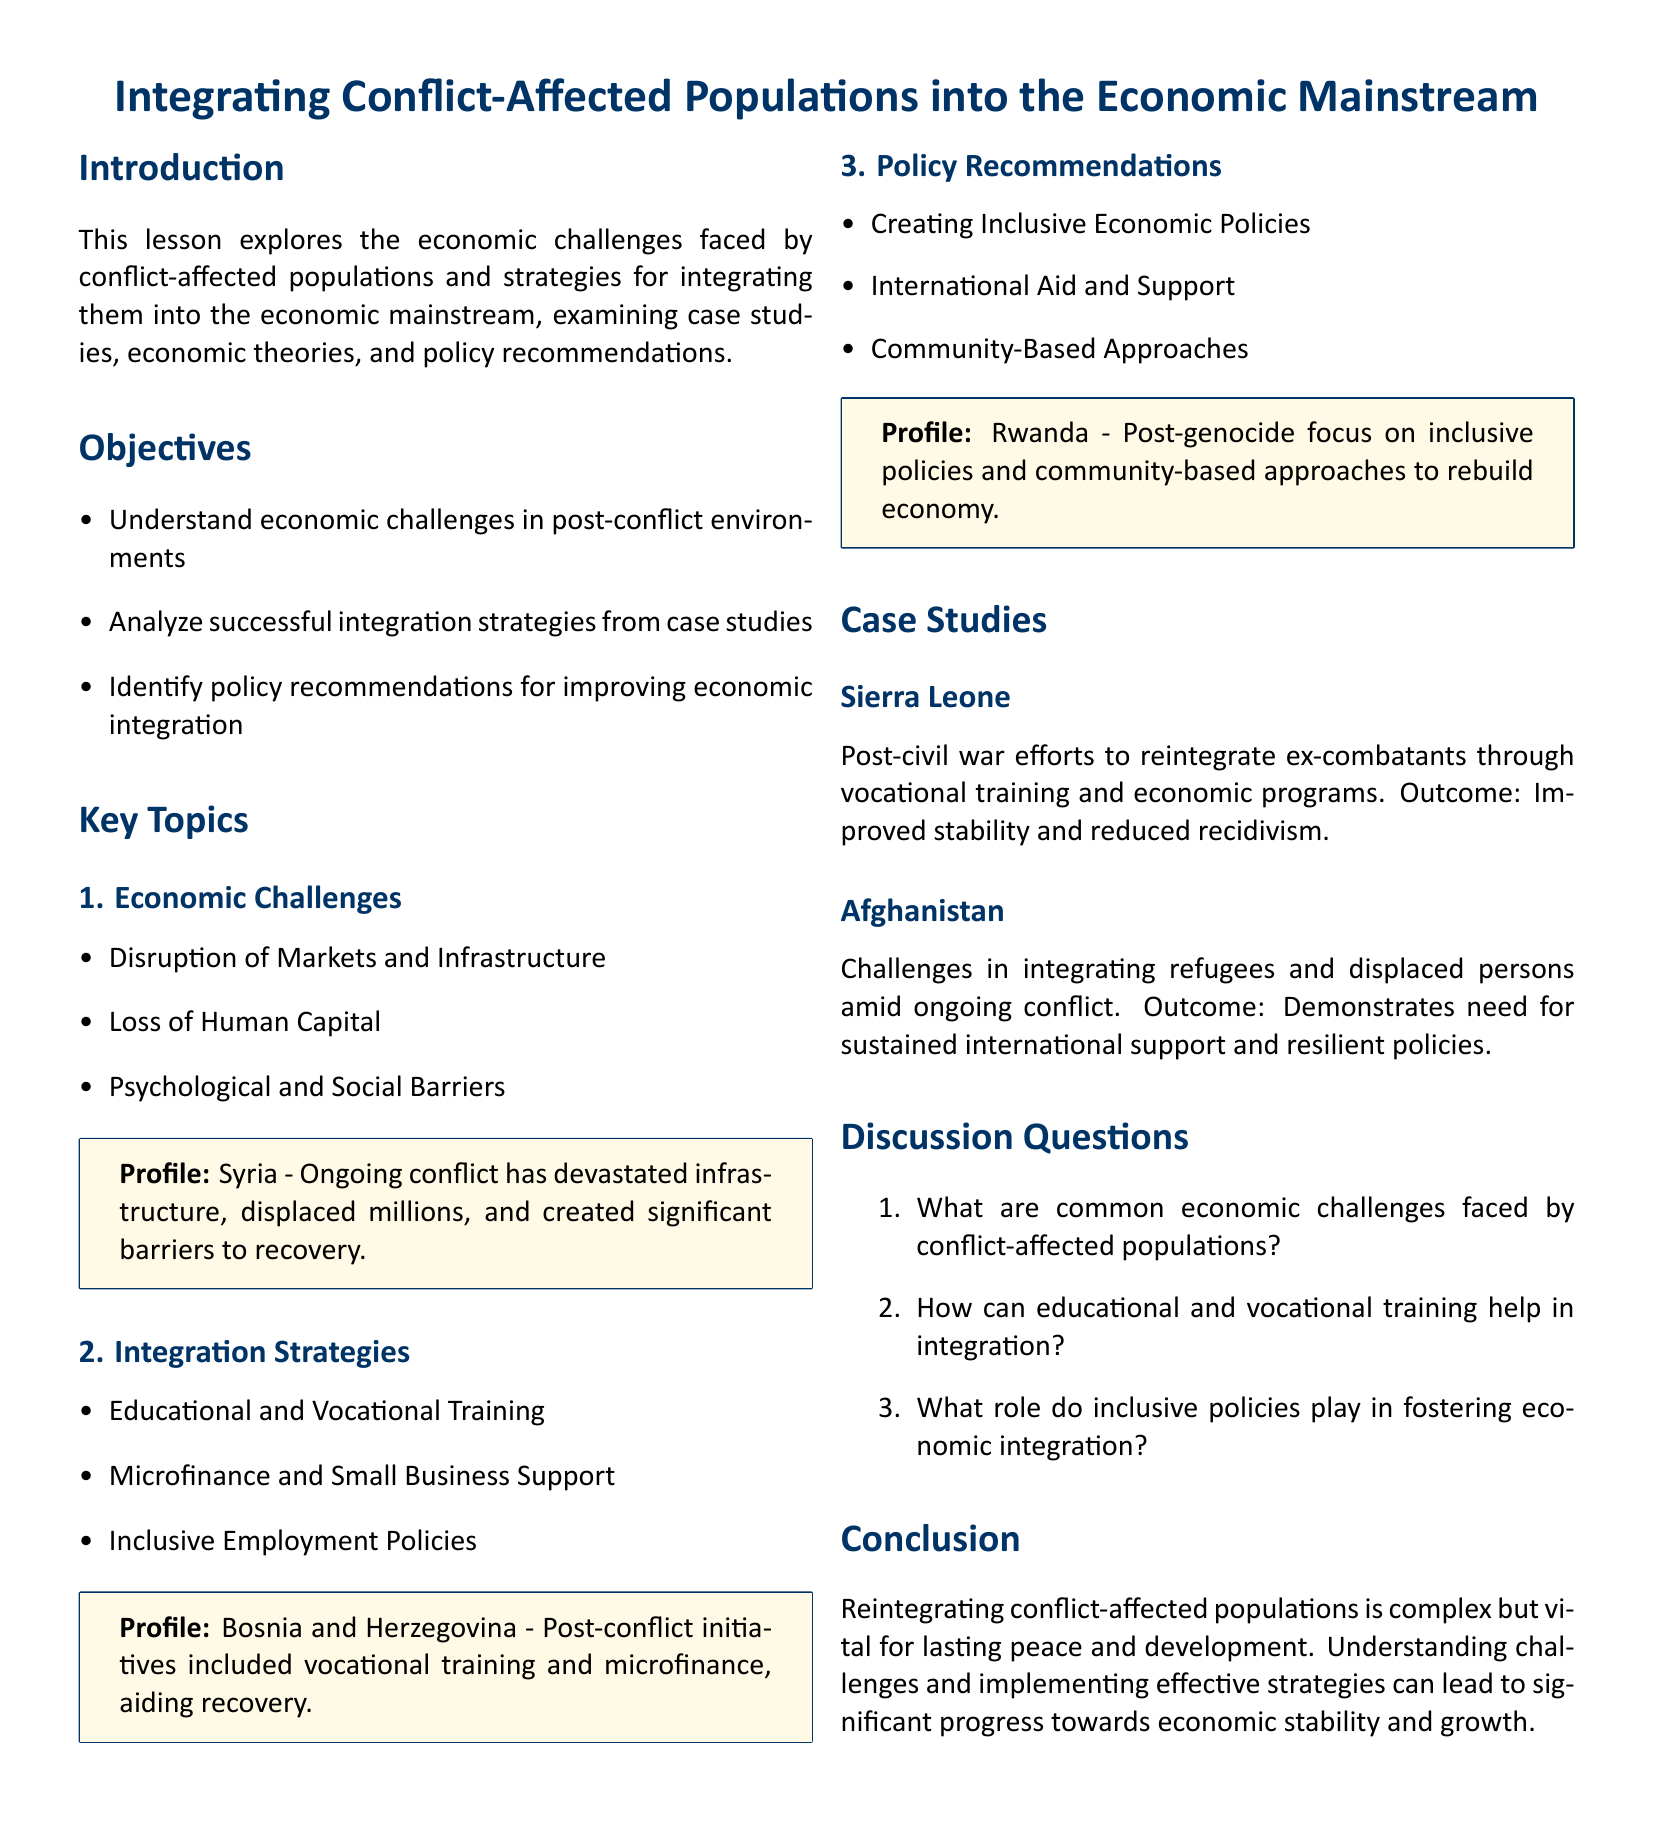What are the economic challenges faced by conflict-affected populations? The document lists several economic challenges including market disruption, loss of human capital, and psychological barriers.
Answer: Market disruption, loss of human capital, psychological barriers What case study is mentioned in relation to Bosnia and Herzegovina? The document mentions post-conflict initiatives in Bosnia and Herzegovina, including vocational training and microfinance.
Answer: Bosnia and Herzegovina Which country is used as a profile to illustrate the impact of ongoing conflict? Syria is the country highlighted as a profile to demonstrate the effects of ongoing conflict on recovery efforts.
Answer: Syria What is one integration strategy mentioned in the lesson plan? The document highlights educational and vocational training as a key integration strategy for conflict-affected populations.
Answer: Educational and vocational training How did the integration efforts impact Sierra Leone? The document states that post-civil war efforts improved stability and reduced recidivism among ex-combatants.
Answer: Improved stability and reduced recidivism What does the conclusion suggest is vital for lasting peace and development? The conclusion emphasizes the importance of reintegrating conflict-affected populations for lasting peace and development.
Answer: Reintegration of conflict-affected populations What type of policies does the lesson recommend creating? The document recommends creating inclusive economic policies to support the integration of conflict-affected populations.
Answer: Inclusive economic policies What is highlighted as essential for improving economic integration? The document mentions international aid and support as crucial for enhancing economic integration in post-conflict scenarios.
Answer: International aid and support 